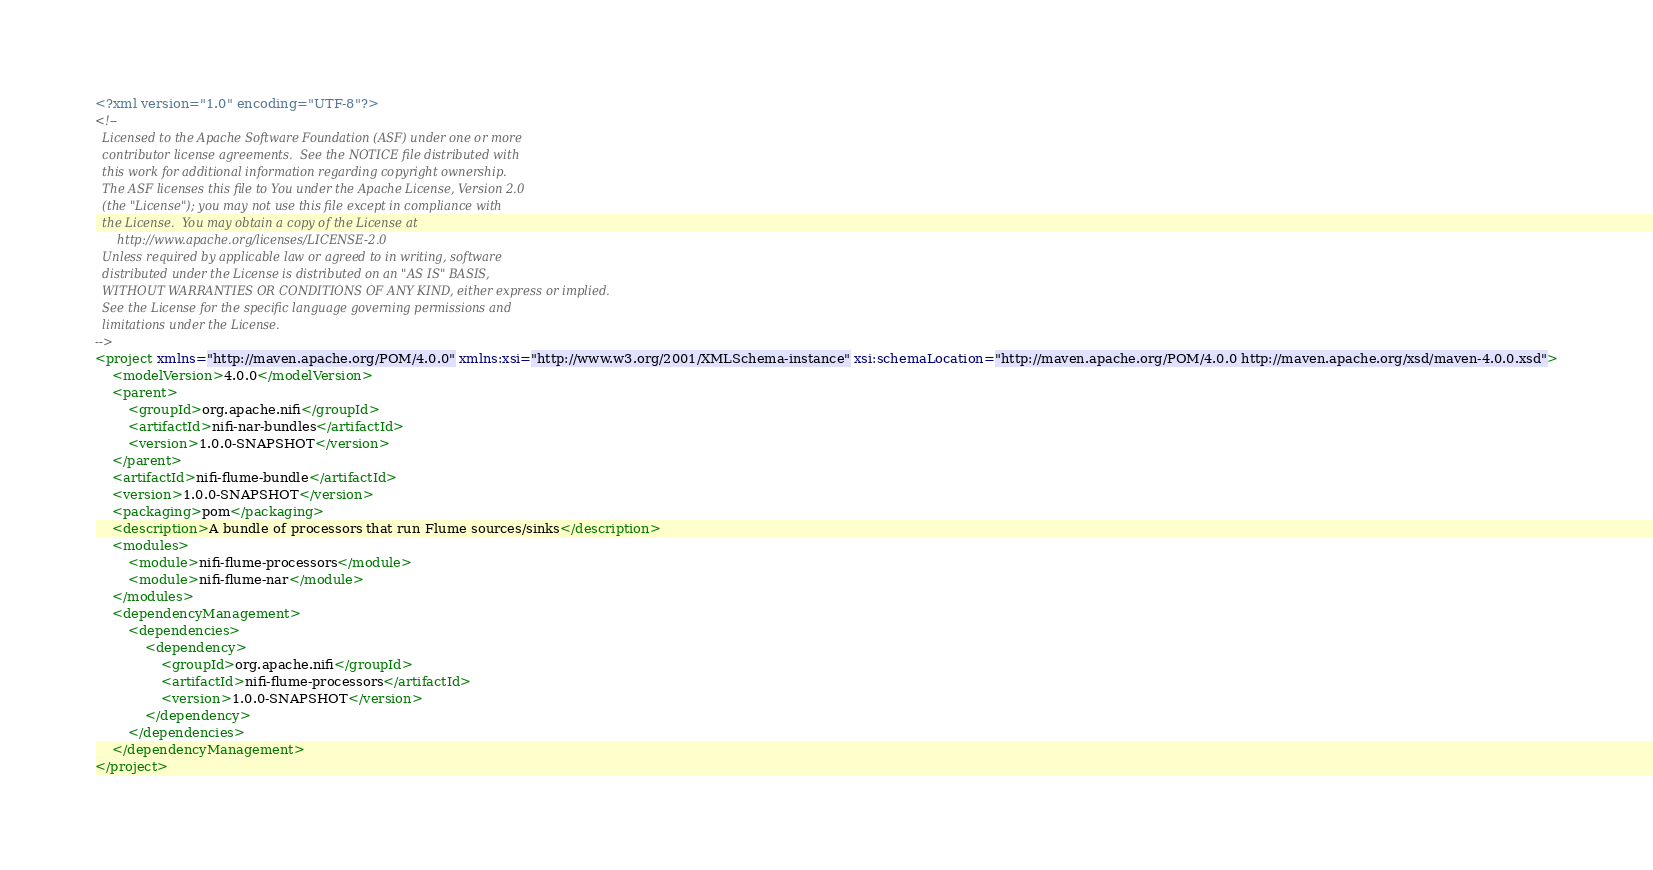Convert code to text. <code><loc_0><loc_0><loc_500><loc_500><_XML_><?xml version="1.0" encoding="UTF-8"?>
<!--
  Licensed to the Apache Software Foundation (ASF) under one or more
  contributor license agreements.  See the NOTICE file distributed with
  this work for additional information regarding copyright ownership.
  The ASF licenses this file to You under the Apache License, Version 2.0
  (the "License"); you may not use this file except in compliance with
  the License.  You may obtain a copy of the License at
      http://www.apache.org/licenses/LICENSE-2.0
  Unless required by applicable law or agreed to in writing, software
  distributed under the License is distributed on an "AS IS" BASIS,
  WITHOUT WARRANTIES OR CONDITIONS OF ANY KIND, either express or implied.
  See the License for the specific language governing permissions and
  limitations under the License.
-->
<project xmlns="http://maven.apache.org/POM/4.0.0" xmlns:xsi="http://www.w3.org/2001/XMLSchema-instance" xsi:schemaLocation="http://maven.apache.org/POM/4.0.0 http://maven.apache.org/xsd/maven-4.0.0.xsd">
    <modelVersion>4.0.0</modelVersion>
    <parent>
        <groupId>org.apache.nifi</groupId>
        <artifactId>nifi-nar-bundles</artifactId>
        <version>1.0.0-SNAPSHOT</version>
    </parent>
    <artifactId>nifi-flume-bundle</artifactId>
    <version>1.0.0-SNAPSHOT</version>
    <packaging>pom</packaging>
    <description>A bundle of processors that run Flume sources/sinks</description>
    <modules>
        <module>nifi-flume-processors</module>
        <module>nifi-flume-nar</module>
    </modules>
    <dependencyManagement>
        <dependencies>
            <dependency>
                <groupId>org.apache.nifi</groupId>
                <artifactId>nifi-flume-processors</artifactId>
                <version>1.0.0-SNAPSHOT</version>
            </dependency>
        </dependencies>
    </dependencyManagement>
</project>
</code> 